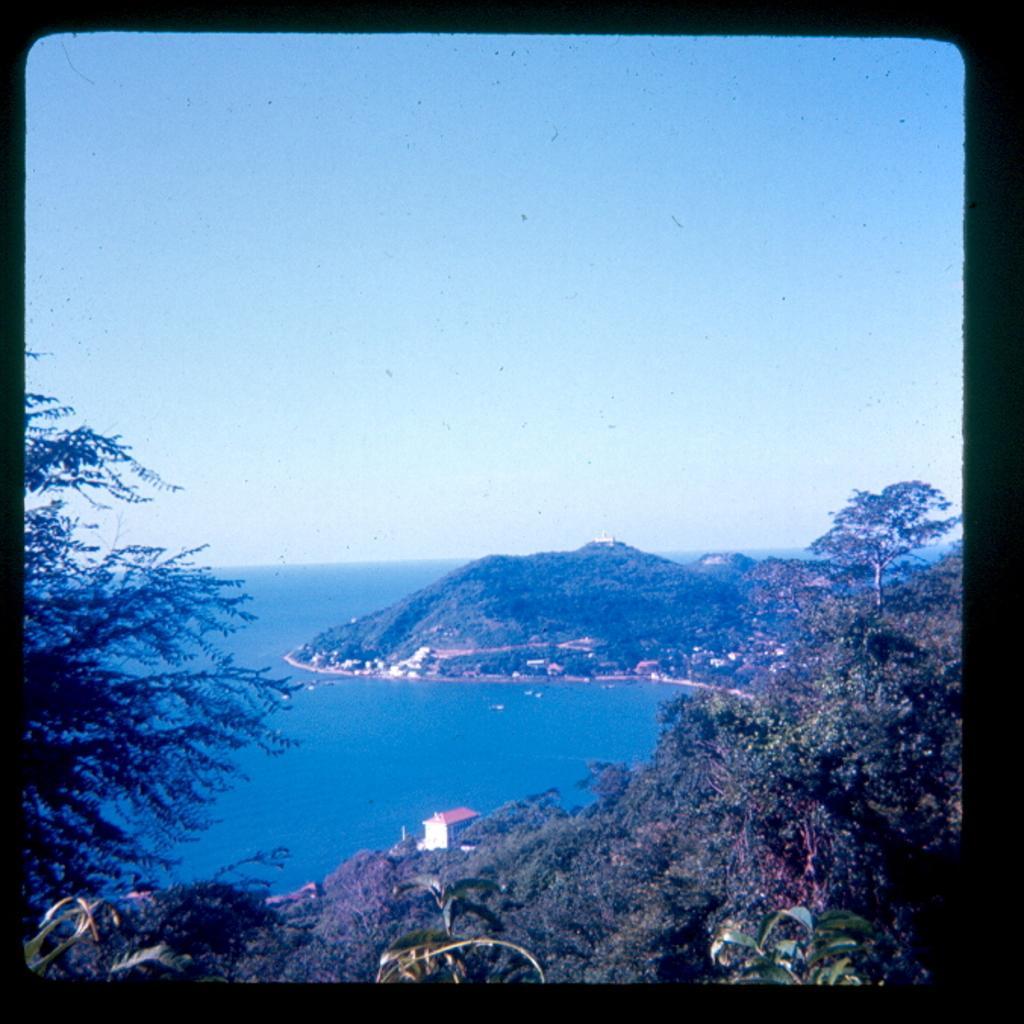Could you give a brief overview of what you see in this image? This is an edited image,in this image there are trees, mountain, houses and the sea, in the background there is the sky. 